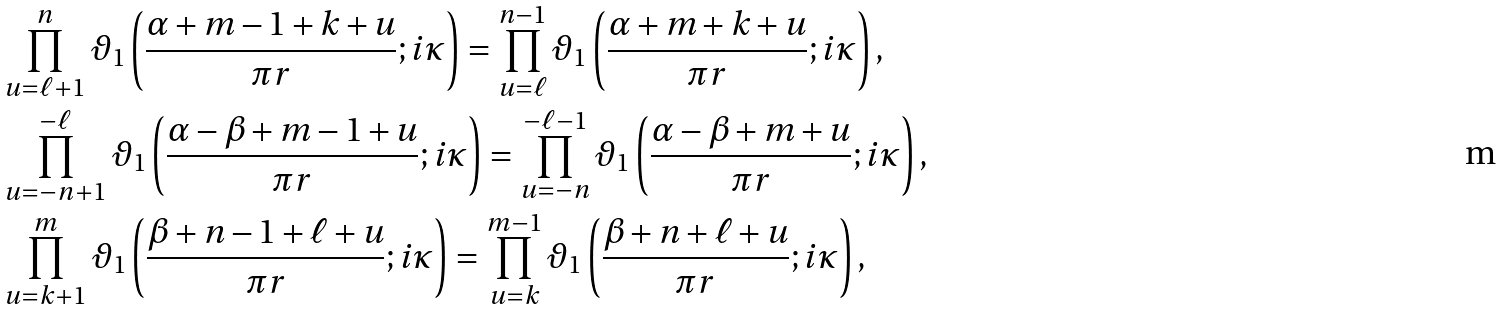Convert formula to latex. <formula><loc_0><loc_0><loc_500><loc_500>& \prod _ { u = \ell + 1 } ^ { n } \vartheta _ { 1 } \left ( \frac { \alpha + m - 1 + k + u } { \pi r } ; i \kappa \right ) = \prod _ { u = \ell } ^ { n - 1 } \vartheta _ { 1 } \left ( \frac { \alpha + m + k + u } { \pi r } ; i \kappa \right ) , \\ & \prod _ { u = - n + 1 } ^ { - \ell } \vartheta _ { 1 } \left ( \frac { \alpha - \beta + m - 1 + u } { \pi r } ; i \kappa \right ) = \prod _ { u = - n } ^ { - \ell - 1 } \vartheta _ { 1 } \left ( \frac { \alpha - \beta + m + u } { \pi r } ; i \kappa \right ) , \\ & \prod _ { u = k + 1 } ^ { m } \vartheta _ { 1 } \left ( \frac { \beta + n - 1 + \ell + u } { \pi r } ; i \kappa \right ) = \prod _ { u = k } ^ { m - 1 } \vartheta _ { 1 } \left ( \frac { \beta + n + \ell + u } { \pi r } ; i \kappa \right ) ,</formula> 